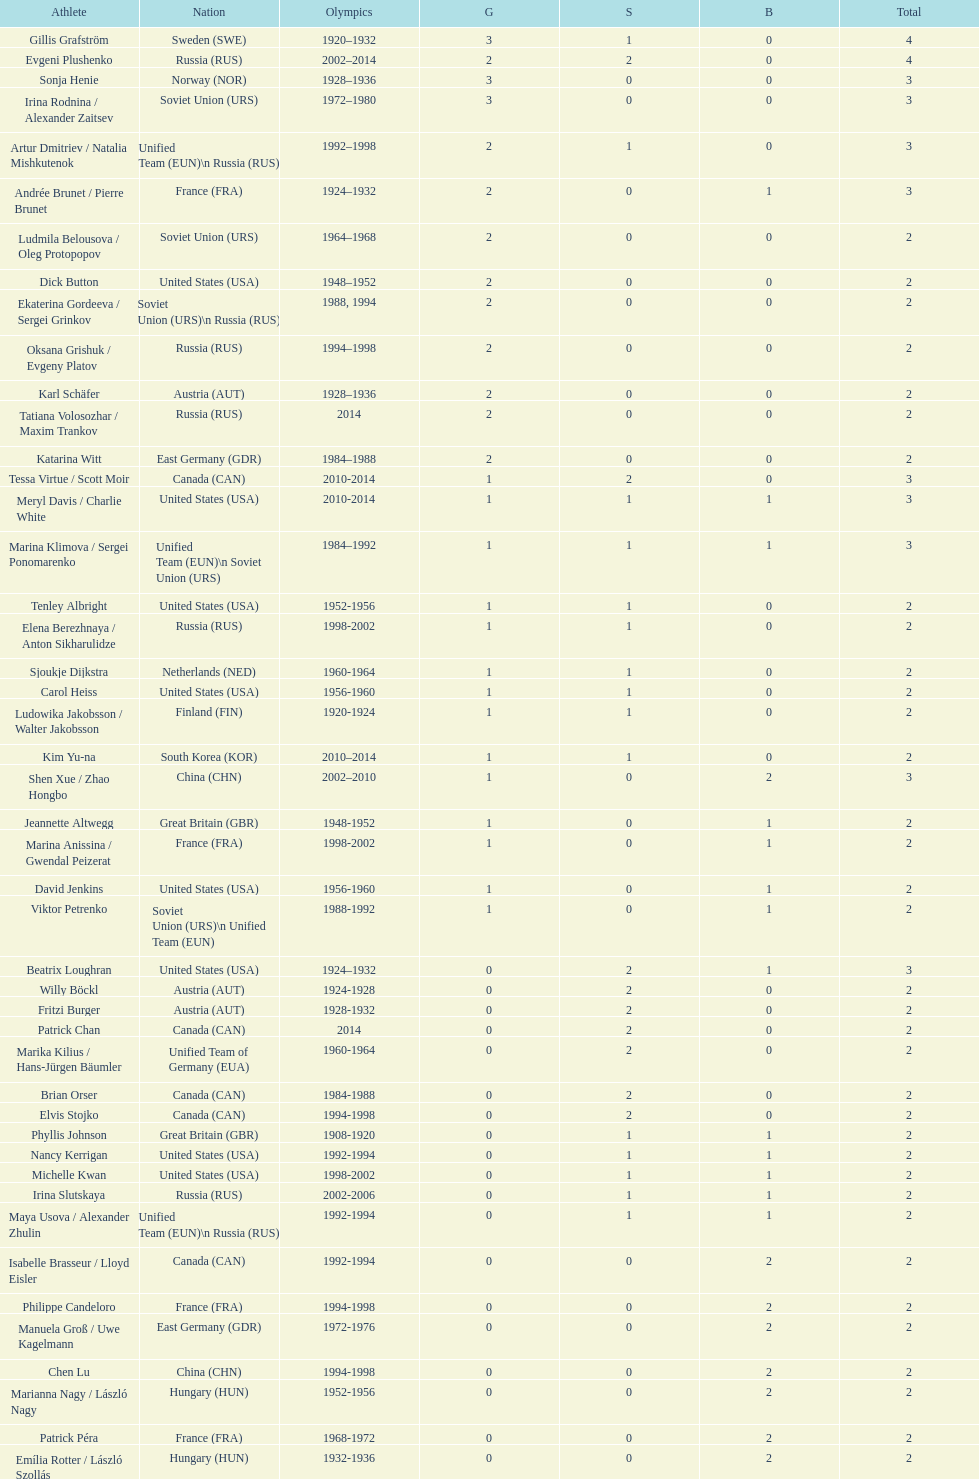Which athlete was from south korea after the year 2010? Kim Yu-na. 